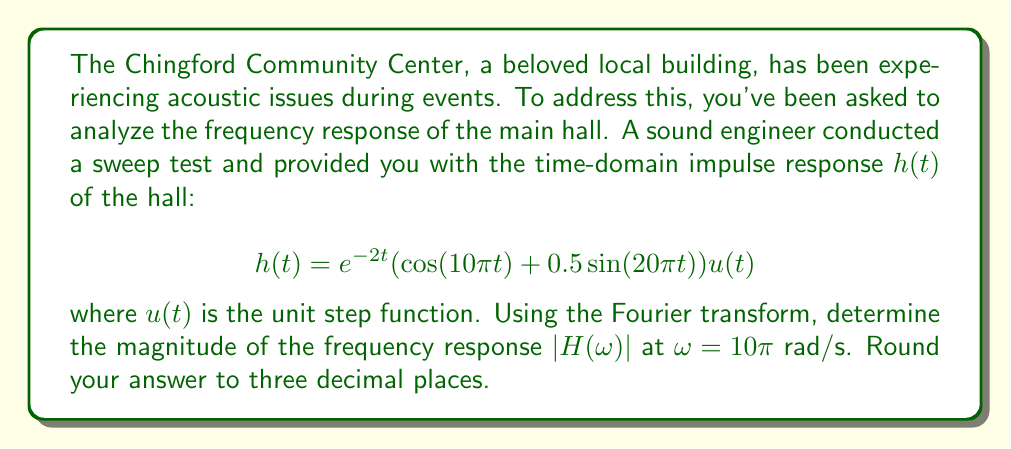Teach me how to tackle this problem. To solve this problem, we'll follow these steps:

1) First, we need to calculate the Fourier transform of $h(t)$ to get $H(\omega)$.

2) The Fourier transform of $h(t) = e^{-at}(\cos(bt) + c\sin(dt))u(t)$ is given by:

   $$H(\omega) = \frac{a+i\omega}{(a+i\omega)^2 + b^2} + \frac{cd}{(a+i\omega)^2 + d^2}$$

3) In our case, $a=2$, $b=10\pi$, $c=0.5$, and $d=20\pi$. Substituting these values:

   $$H(\omega) = \frac{2+i\omega}{(2+i\omega)^2 + (10\pi)^2} + \frac{0.5(20\pi)}{(2+i\omega)^2 + (20\pi)^2}$$

4) We need to find $|H(\omega)|$ at $\omega = 10\pi$. Let's substitute this:

   $$H(10\pi) = \frac{2+i10\pi}{(2+i10\pi)^2 + (10\pi)^2} + \frac{10\pi}{(2+i10\pi)^2 + (20\pi)^2}$$

5) To find the magnitude, we need to calculate $|H(10\pi)| = \sqrt{\text{Re}(H(10\pi))^2 + \text{Im}(H(10\pi))^2}$

6) This involves complex arithmetic. After simplification:

   $$|H(10\pi)| = \sqrt{\left(\frac{2}{404\pi^2+4} + \frac{10\pi}{1604\pi^2+4}\right)^2 + \left(\frac{10\pi}{404\pi^2+4} - \frac{2}{1604\pi^2+4}\right)^2}$$

7) Evaluating this expression numerically and rounding to three decimal places gives us the final answer.
Answer: $|H(10\pi)| \approx 0.016$ 